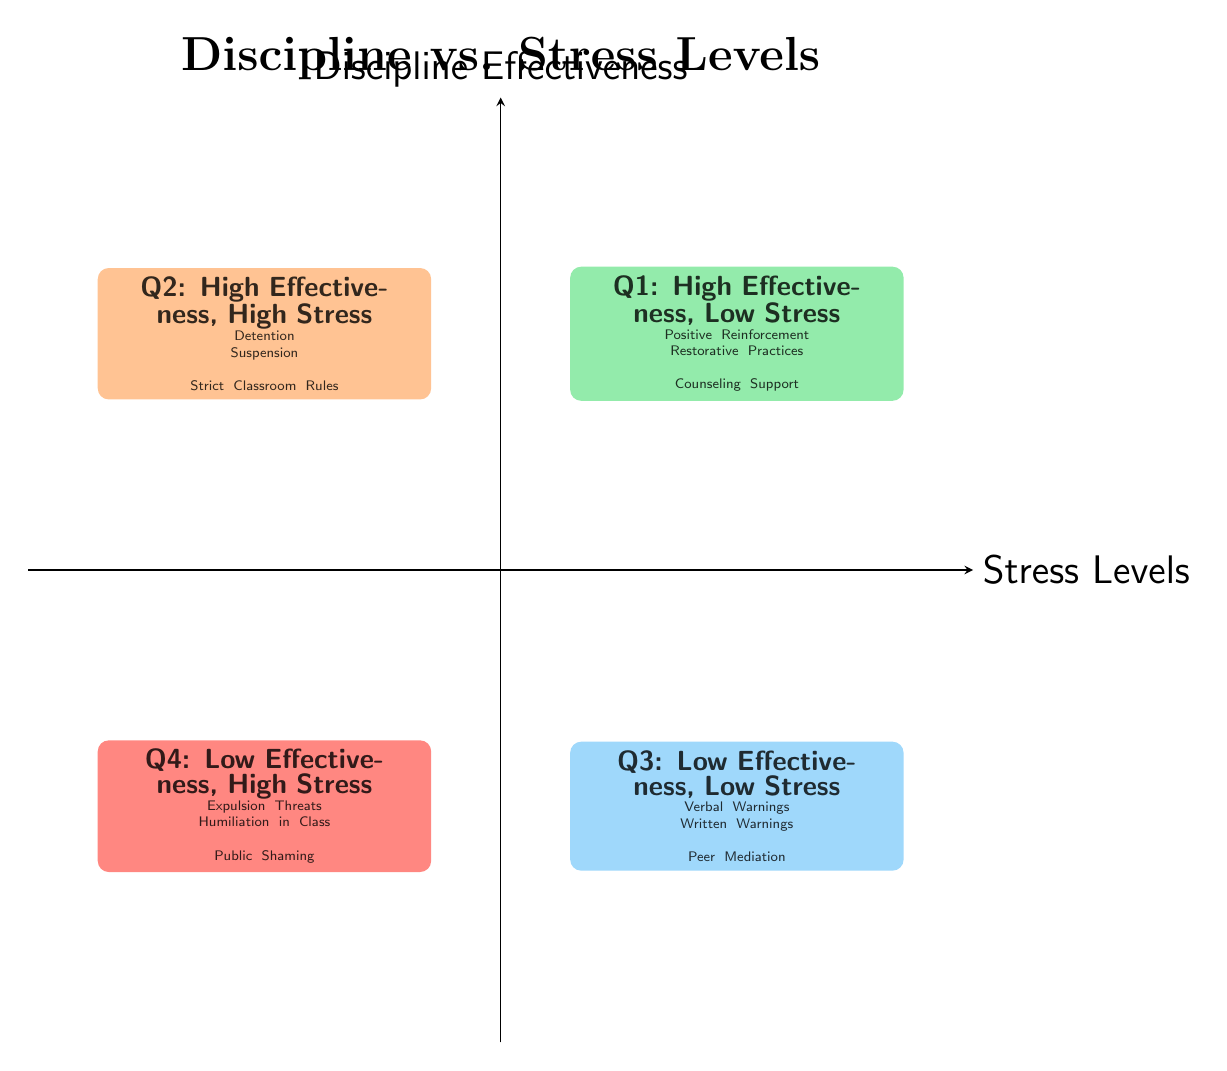What is the main title of the diagram? The title of the diagram is located at the top and it is clearly labeled as "Discipline vs. Stress Levels."
Answer: Discipline vs. Stress Levels Which quadrant contains "Positive Reinforcement"? "Positive Reinforcement" is listed under the description of Q1, which is identified as "High Effectiveness, Low Stress."
Answer: Q1 How many examples are provided in Q2? Q2 includes three examples of disciplinary actions, which are "Detention," "Suspension," and "Strict Classroom Rules."
Answer: 3 What are the examples mentioned in Q4? Q4 lists three examples: "Expulsion Threats," "Humiliation in Class," and "Public Shaming." These actions fall under low effectiveness and high stress.
Answer: Expulsion Threats, Humiliation in Class, Public Shaming Which quadrant is characterized by effective actions that also increase stress? Q2, which is labeled "High Effectiveness, High Stress," includes disciplinary actions that improve behavior but cause stress.
Answer: Q2 How does "Counseling Support" affect stress levels according to the diagram? "Counseling Support" is found in Q1, which suggests it is effective for improving behavior without significantly increasing stress levels; thus, it likely helps reduce stress.
Answer: Reduces stress What relationship exists between the examples in Q3 and their effectiveness? The examples in Q3, such as "Verbal Warnings," are characterized as having low effectiveness in improving behavior while also maintaining low stress levels for students.
Answer: Low effectiveness, Low stress Which quadrant is the least beneficial according to the chart? Q4 is labeled "Low Effectiveness, High Stress," indicating it is the least beneficial as it neither improves behavior nor reduces stress.
Answer: Q4 What is the defining feature of the quadrants on the left side of the diagram? The left side of the diagram (Q2 and Q4) is characterized by high stress levels, as both quadrants represent disciplinary actions associated with increased stress for students.
Answer: High stress levels 